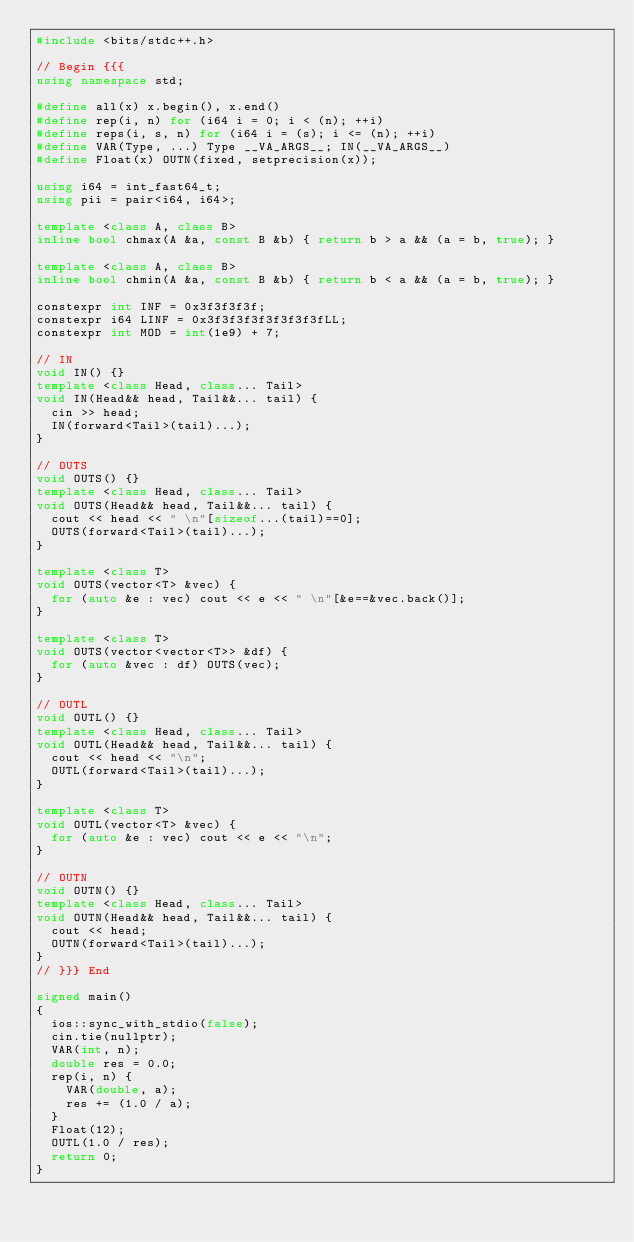Convert code to text. <code><loc_0><loc_0><loc_500><loc_500><_C++_>#include <bits/stdc++.h>

// Begin {{{
using namespace std;

#define all(x) x.begin(), x.end()
#define rep(i, n) for (i64 i = 0; i < (n); ++i)
#define reps(i, s, n) for (i64 i = (s); i <= (n); ++i)
#define VAR(Type, ...) Type __VA_ARGS__; IN(__VA_ARGS__)
#define Float(x) OUTN(fixed, setprecision(x));

using i64 = int_fast64_t;
using pii = pair<i64, i64>;

template <class A, class B>
inline bool chmax(A &a, const B &b) { return b > a && (a = b, true); }

template <class A, class B>
inline bool chmin(A &a, const B &b) { return b < a && (a = b, true); }

constexpr int INF = 0x3f3f3f3f;
constexpr i64 LINF = 0x3f3f3f3f3f3f3f3fLL;
constexpr int MOD = int(1e9) + 7;

// IN
void IN() {}
template <class Head, class... Tail>
void IN(Head&& head, Tail&&... tail) {
  cin >> head;
  IN(forward<Tail>(tail)...);
}

// OUTS
void OUTS() {}
template <class Head, class... Tail>
void OUTS(Head&& head, Tail&&... tail) {
  cout << head << " \n"[sizeof...(tail)==0];
  OUTS(forward<Tail>(tail)...);
}

template <class T>
void OUTS(vector<T> &vec) {
  for (auto &e : vec) cout << e << " \n"[&e==&vec.back()];
}

template <class T>
void OUTS(vector<vector<T>> &df) {
  for (auto &vec : df) OUTS(vec);
}

// OUTL
void OUTL() {}
template <class Head, class... Tail>
void OUTL(Head&& head, Tail&&... tail) {
  cout << head << "\n";
  OUTL(forward<Tail>(tail)...);
}

template <class T>
void OUTL(vector<T> &vec) {
  for (auto &e : vec) cout << e << "\n";
}

// OUTN
void OUTN() {}
template <class Head, class... Tail>
void OUTN(Head&& head, Tail&&... tail) {
  cout << head;
  OUTN(forward<Tail>(tail)...);
}
// }}} End

signed main()
{
  ios::sync_with_stdio(false);
  cin.tie(nullptr);
  VAR(int, n);
  double res = 0.0;
  rep(i, n) {
    VAR(double, a);
    res += (1.0 / a);
  }
  Float(12);
  OUTL(1.0 / res);
  return 0;
}
</code> 